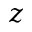<formula> <loc_0><loc_0><loc_500><loc_500>z</formula> 